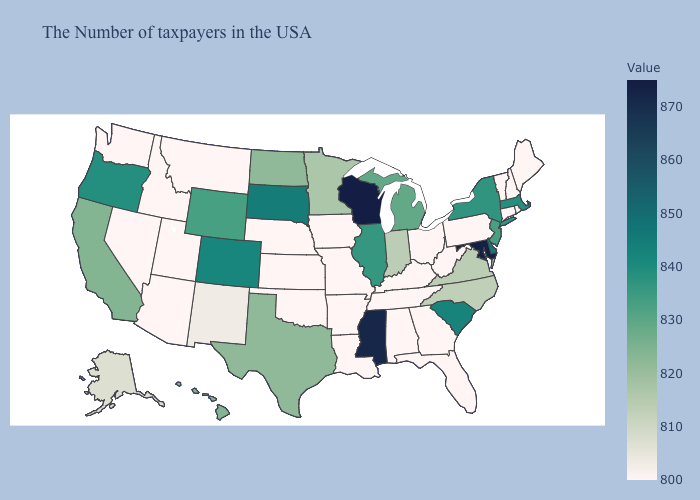Does Louisiana have the lowest value in the USA?
Short answer required. Yes. Does North Carolina have a lower value than Nebraska?
Concise answer only. No. Among the states that border Iowa , which have the highest value?
Concise answer only. Wisconsin. 